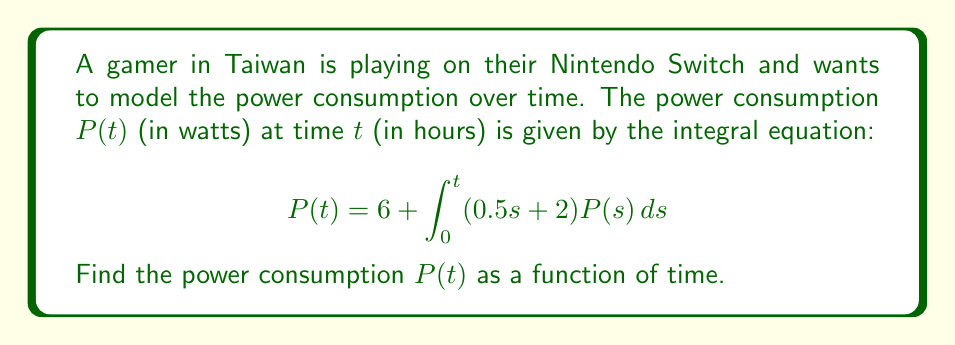Help me with this question. Let's solve this integral equation step by step:

1) First, we recognize this as a Volterra integral equation of the second kind.

2) We can solve this using the method of successive approximations (Picard iteration).

3) Let's start with $P_0(t) = 6$ as our initial approximation.

4) We'll use this to generate the next approximation:

   $$P_1(t) = 6 + \int_0^t (0.5s + 2) P_0(s) ds = 6 + \int_0^t (0.5s + 2) 6 ds$$

5) Solving this integral:

   $$P_1(t) = 6 + 6 \int_0^t (0.5s + 2) ds = 6 + 6 [0.25s^2 + 2s]_0^t = 6 + 6(0.25t^2 + 2t)$$

6) Simplifying:

   $$P_1(t) = 6 + 1.5t^2 + 12t = 1.5t^2 + 12t + 6$$

7) We could continue this process, but we notice that $P_1(t)$ is already in the form of a quadratic function.

8) Let's assume the general solution is of the form $P(t) = at^2 + bt + c$.

9) Substituting this into the original equation:

   $$at^2 + bt + c = 6 + \int_0^t (0.5s + 2)(as^2 + bs + c) ds$$

10) Solving the right-hand side integral:

    $$6 + [\frac{a}{8}s^4 + \frac{a}{3}s^3 + \frac{b}{6}s^3 + \frac{b}{2}s^2 + \frac{c}{4}s^2 + 2cs]_0^t$$
    
    $$= 6 + \frac{a}{8}t^4 + \frac{a}{3}t^3 + \frac{b}{6}t^3 + \frac{b}{2}t^2 + \frac{c}{4}t^2 + 2ct$$

11) Equating coefficients:

    $t^4: a = \frac{a}{8}$
    $t^3: 0 = \frac{a}{3} + \frac{b}{6}$
    $t^2: a = \frac{b}{2} + \frac{c}{4}$
    $t^1: b = 2c$
    $t^0: c = 6$

12) Solving this system of equations:

    $c = 6$
    $b = 12$
    $a = 1.5$

Therefore, the solution is $P(t) = 1.5t^2 + 12t + 6$.
Answer: $P(t) = 1.5t^2 + 12t + 6$ 